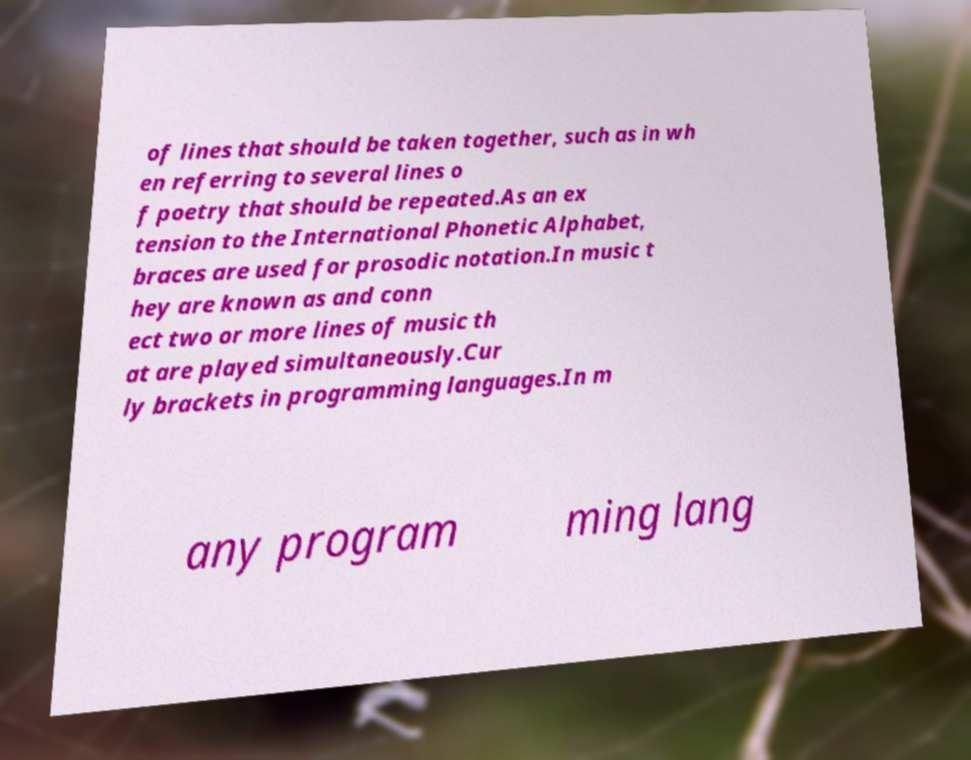Please read and relay the text visible in this image. What does it say? of lines that should be taken together, such as in wh en referring to several lines o f poetry that should be repeated.As an ex tension to the International Phonetic Alphabet, braces are used for prosodic notation.In music t hey are known as and conn ect two or more lines of music th at are played simultaneously.Cur ly brackets in programming languages.In m any program ming lang 